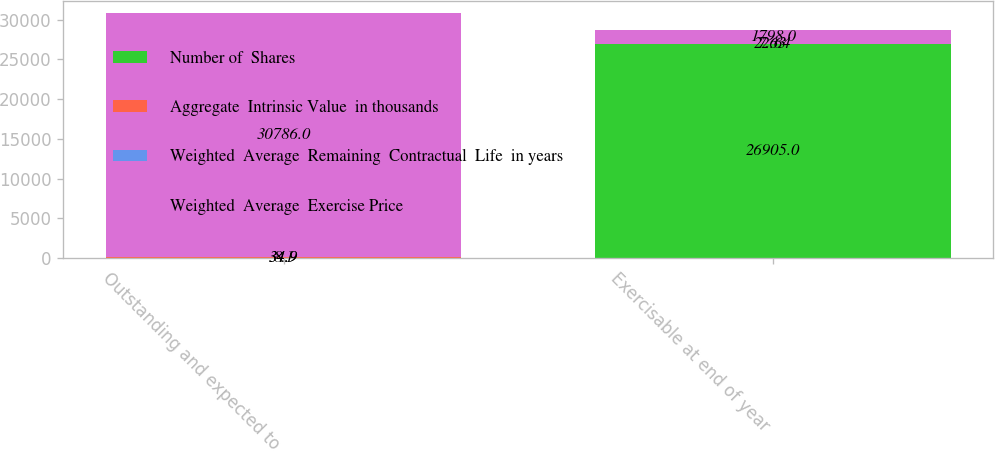<chart> <loc_0><loc_0><loc_500><loc_500><stacked_bar_chart><ecel><fcel>Outstanding and expected to<fcel>Exercisable at end of year<nl><fcel>Number of  Shares<fcel>34.9<fcel>26905<nl><fcel>Aggregate  Intrinsic Value  in thousands<fcel>34.9<fcel>22.64<nl><fcel>Weighted  Average  Remaining  Contractual  Life  in years<fcel>8.1<fcel>7.63<nl><fcel>Weighted  Average  Exercise Price<fcel>30786<fcel>1798<nl></chart> 